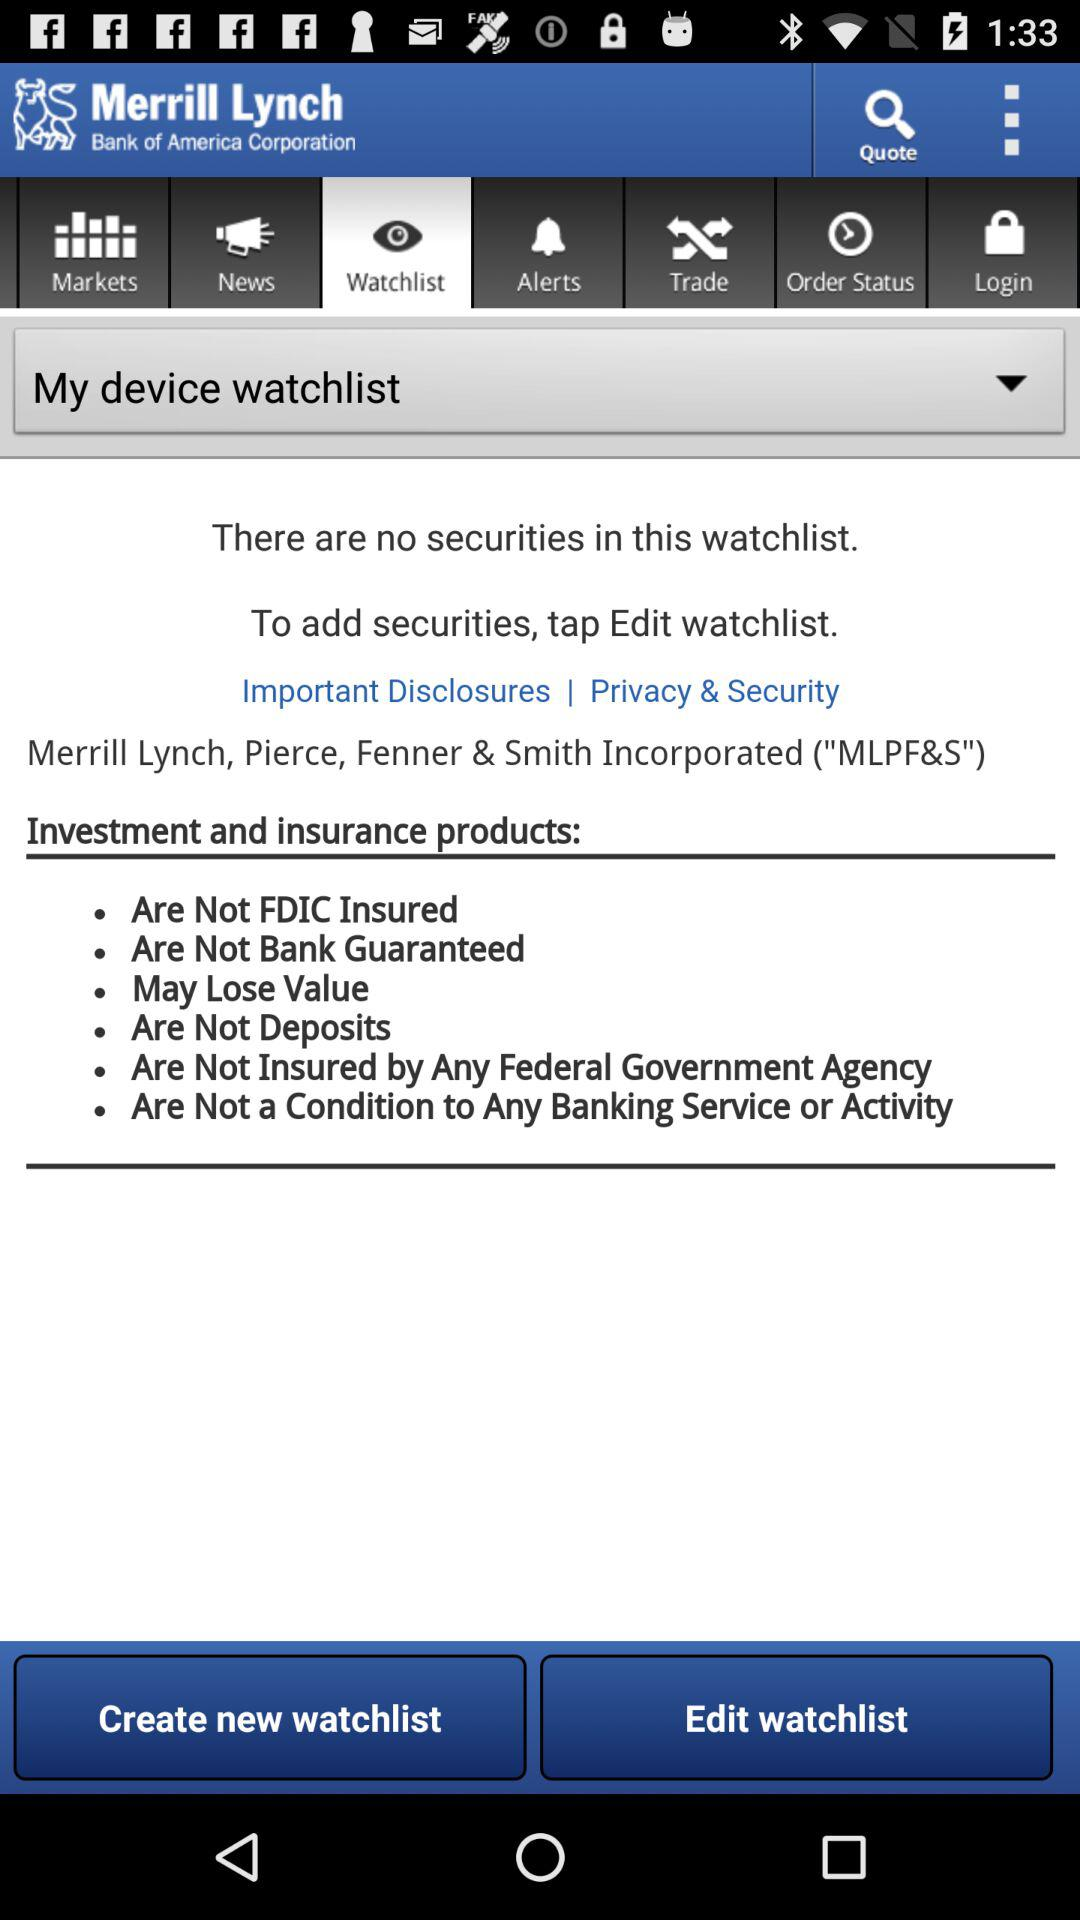What is the name of the application? The name of the application is "MyMerrill". 